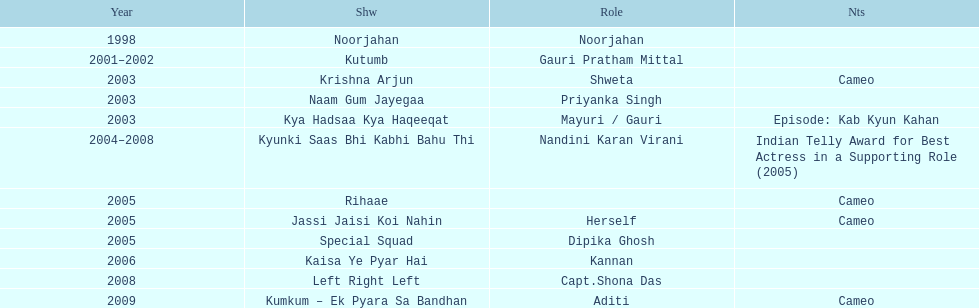Before the turn of the millennium, in how many television shows did gauri tejwani participate? 1. 